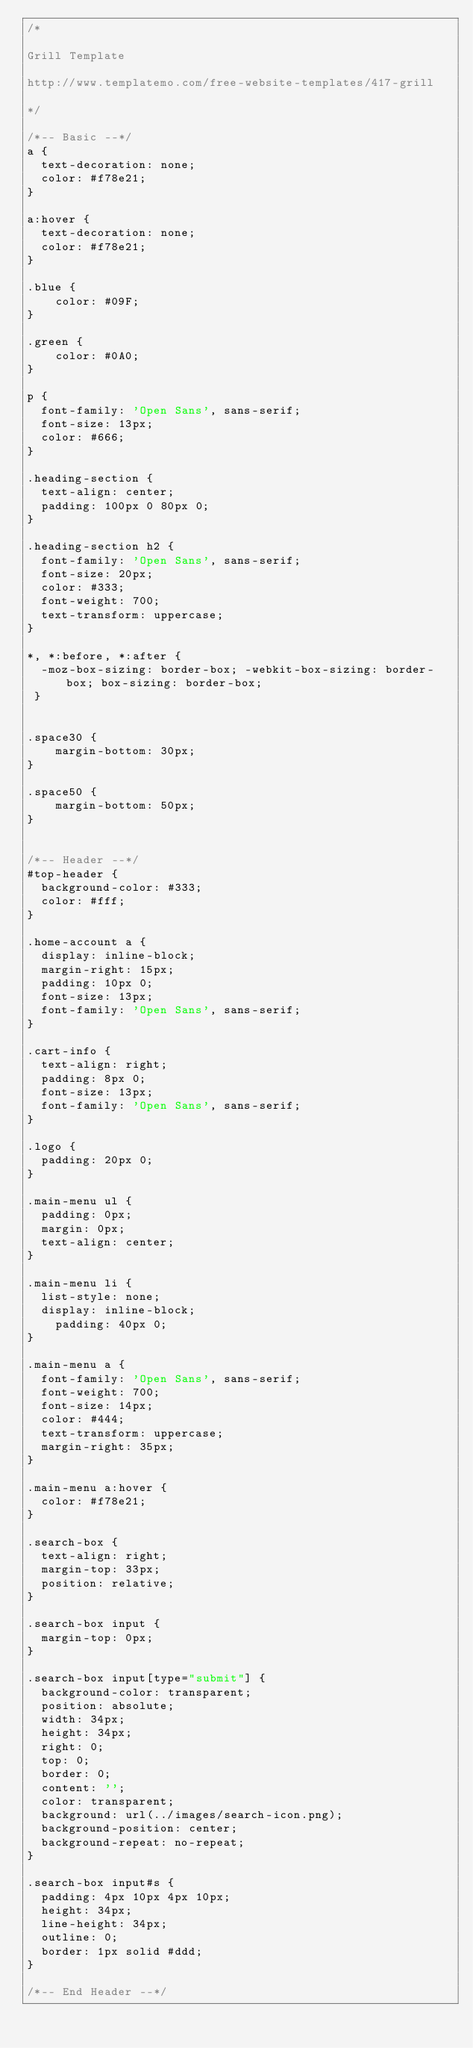Convert code to text. <code><loc_0><loc_0><loc_500><loc_500><_CSS_>/*

Grill Template 

http://www.templatemo.com/free-website-templates/417-grill

*/

/*-- Basic --*/
a {
  text-decoration: none;
  color: #f78e21;
}

a:hover {
  text-decoration: none;
  color: #f78e21;
}

.blue {
	color: #09F;
}

.green {
	color: #0A0;
}

p {
  font-family: 'Open Sans', sans-serif;
  font-size: 13px;
  color: #666;
}

.heading-section {
  text-align: center;
  padding: 100px 0 80px 0;
}

.heading-section h2 {
  font-family: 'Open Sans', sans-serif;
  font-size: 20px;
  color: #333;
  font-weight: 700;
  text-transform: uppercase;
}

*, *:before, *:after {
  -moz-box-sizing: border-box; -webkit-box-sizing: border-box; box-sizing: border-box;
 }


.space30 {
	margin-bottom: 30px;
}

.space50 {
	margin-bottom: 50px;
}


/*-- Header --*/
#top-header {
  background-color: #333;
  color: #fff;
}

.home-account a {
  display: inline-block;
  margin-right: 15px;
  padding: 10px 0;
  font-size: 13px;
  font-family: 'Open Sans', sans-serif;
}

.cart-info {
  text-align: right;
  padding: 8px 0;
  font-size: 13px;
  font-family: 'Open Sans', sans-serif;
}

.logo {
  padding: 20px 0;
}

.main-menu ul {
  padding: 0px;
  margin: 0px;
  text-align: center;
}

.main-menu li {
  list-style: none;
  display: inline-block;
    padding: 40px 0;
}

.main-menu a {
  font-family: 'Open Sans', sans-serif;
  font-weight: 700;
  font-size: 14px;
  color: #444;
  text-transform: uppercase;
  margin-right: 35px;
}

.main-menu a:hover {
  color: #f78e21;
}

.search-box {
  text-align: right;
  margin-top: 33px;
  position: relative;
}

.search-box input {
  margin-top: 0px;
}

.search-box input[type="submit"] {
  background-color: transparent;
  position: absolute;
  width: 34px;
  height: 34px;
  right: 0;
  top: 0;
  border: 0;
  content: '';
  color: transparent;
  background: url(../images/search-icon.png);
  background-position: center;
  background-repeat: no-repeat;
}

.search-box input#s {
  padding: 4px 10px 4px 10px;
  height: 34px;
  line-height: 34px;
  outline: 0;
  border: 1px solid #ddd;
}

/*-- End Header --*/



</code> 